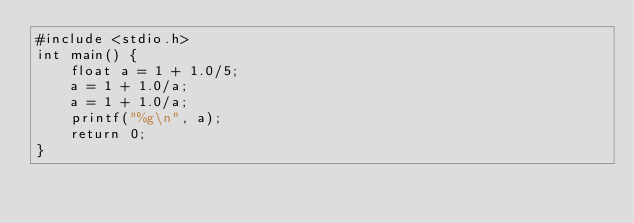Convert code to text. <code><loc_0><loc_0><loc_500><loc_500><_C_>#include <stdio.h>
int main() {
    float a = 1 + 1.0/5;
    a = 1 + 1.0/a;
    a = 1 + 1.0/a;
    printf("%g\n", a);
    return 0;
}
</code> 